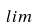<formula> <loc_0><loc_0><loc_500><loc_500>l i m</formula> 